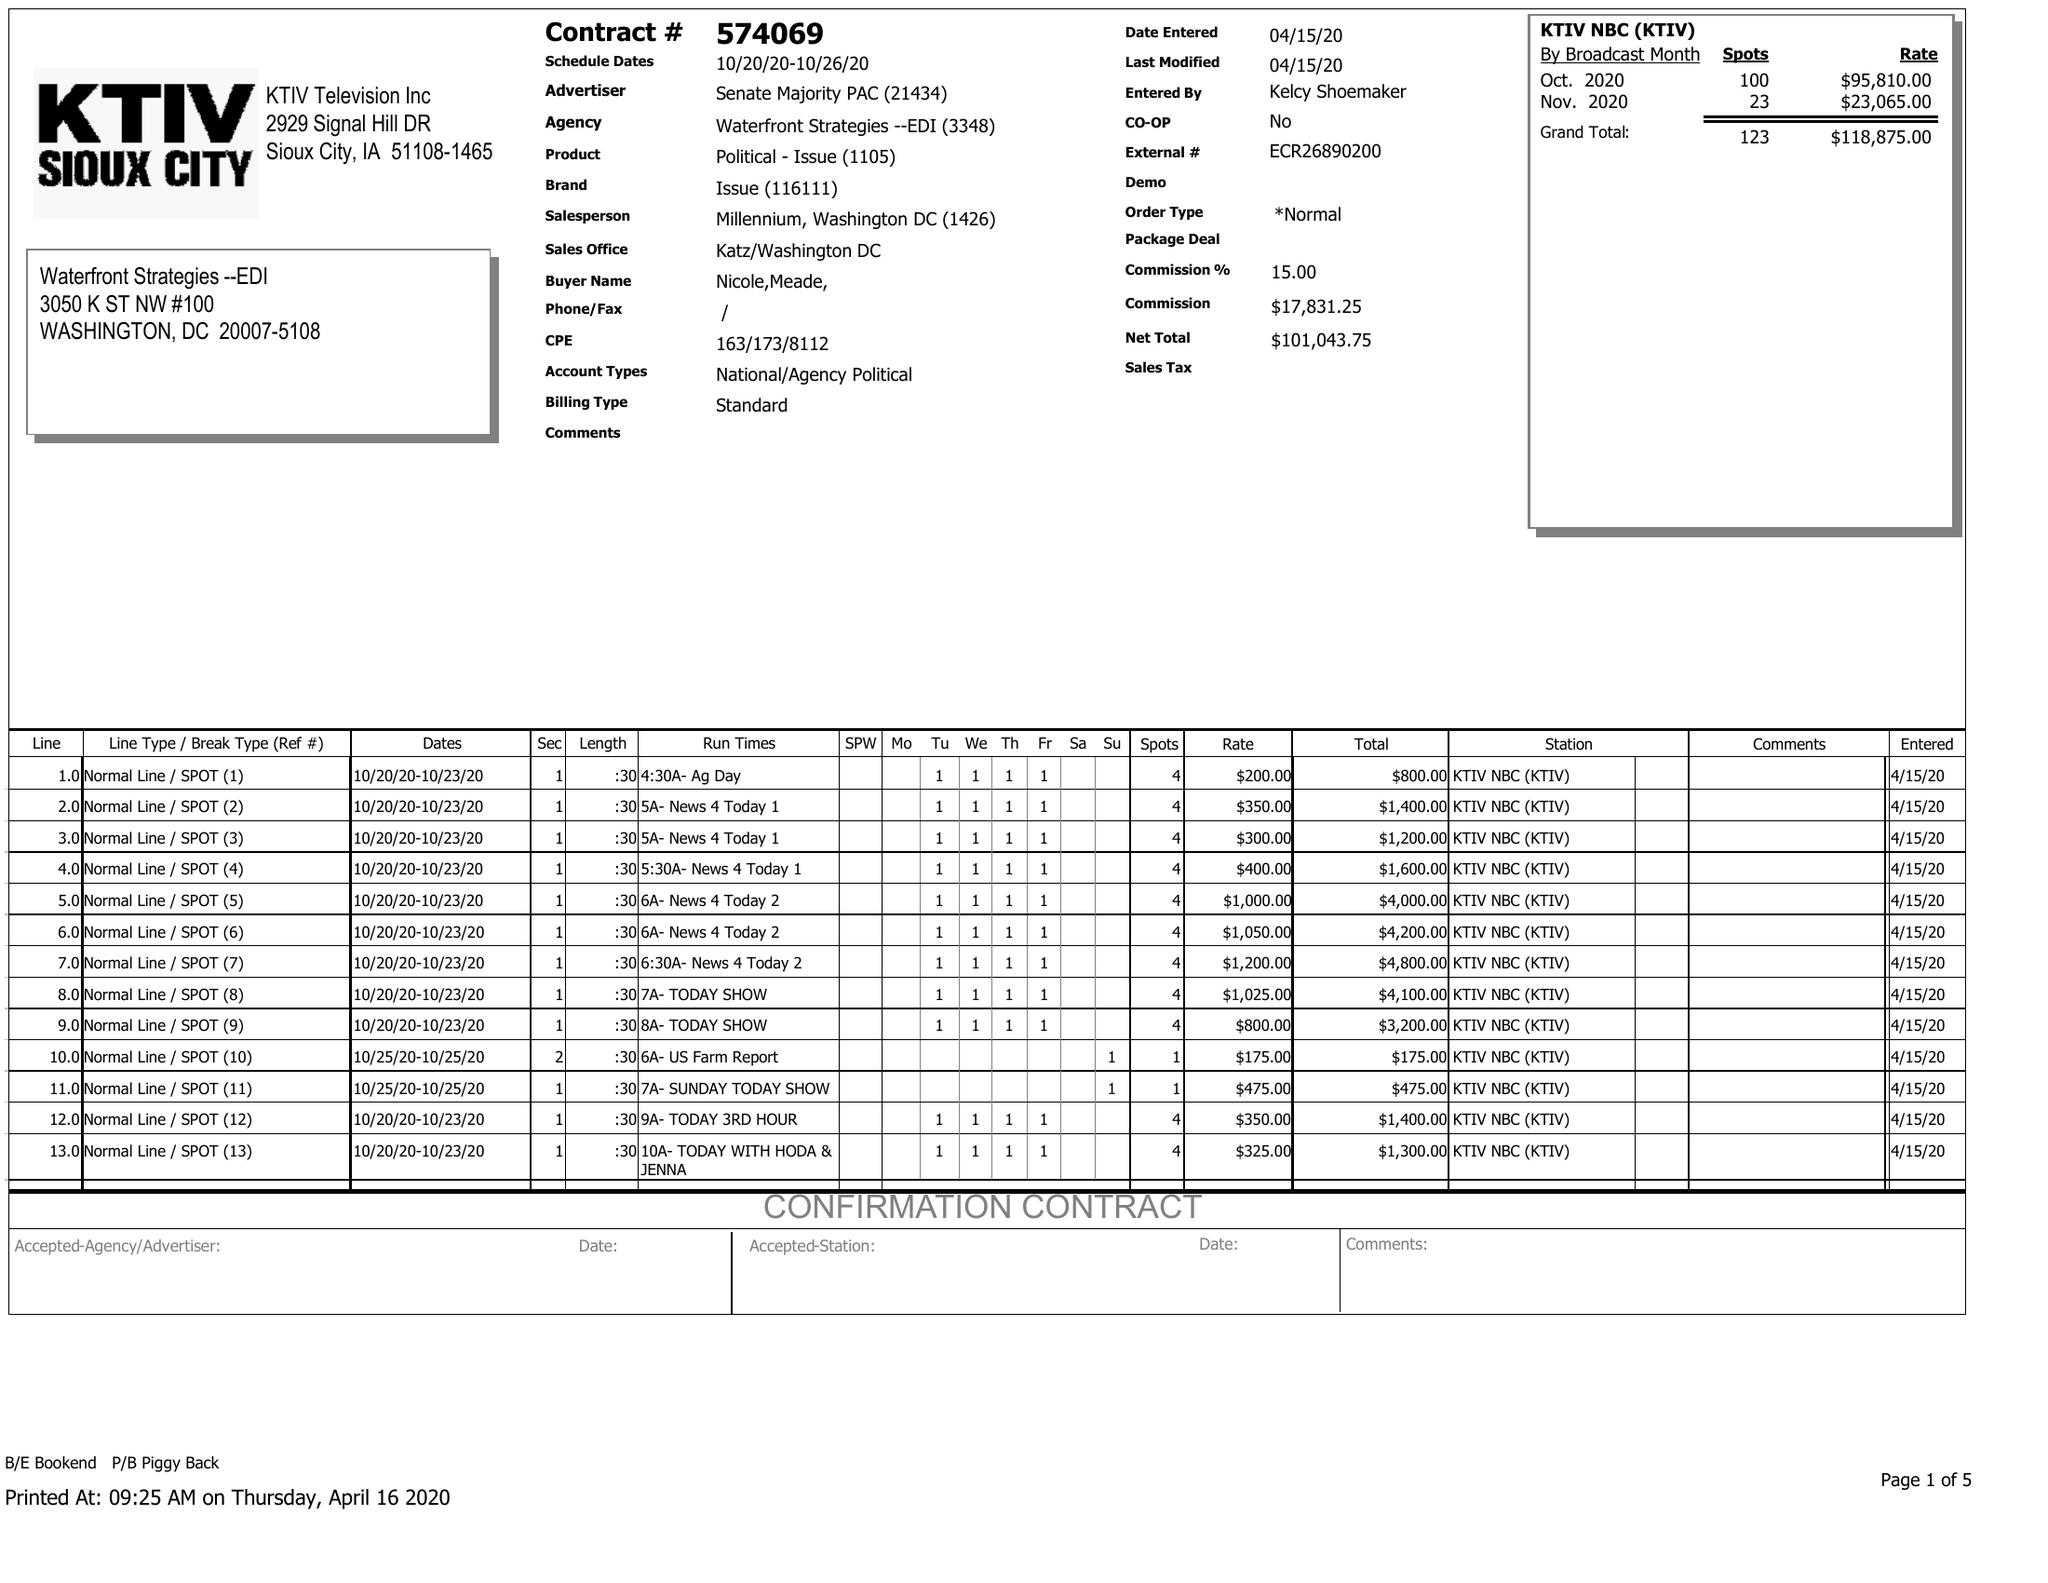What is the value for the flight_from?
Answer the question using a single word or phrase. 10/20/20 